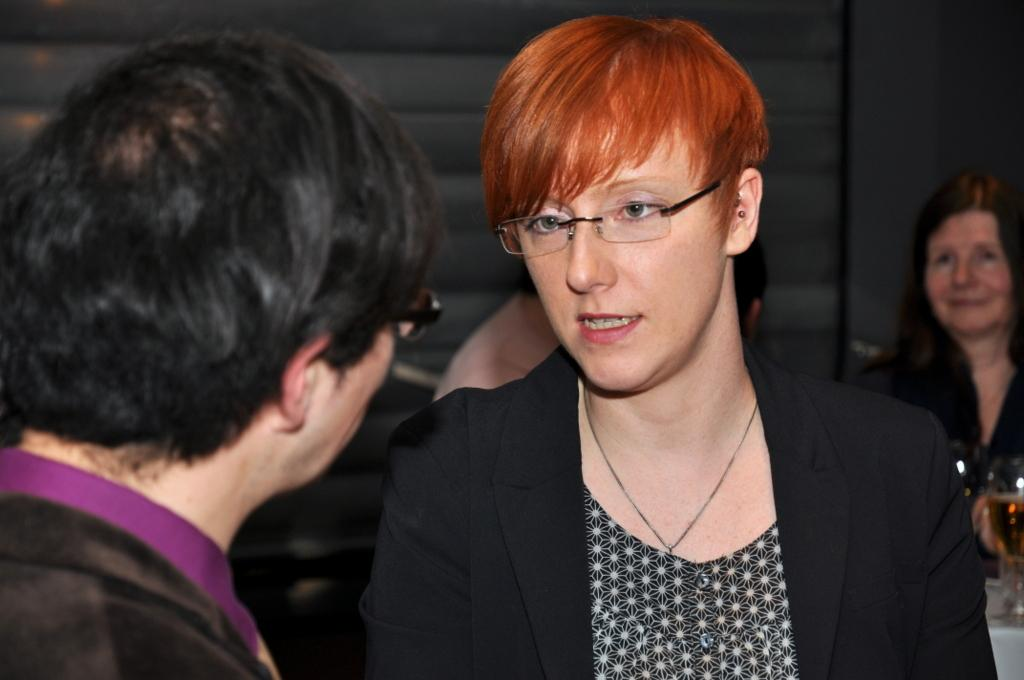What is the main subject of the image? The main subject of the image is a group of people. What objects can be seen on a table in the image? There are glasses on a table in the image. What type of structure is visible in the image? There is a wall in the image. What type of fire can be seen burning on the ground in the image? There is no fire or ground visible in the image; it features a group of people, glasses on a table, and a wall. 